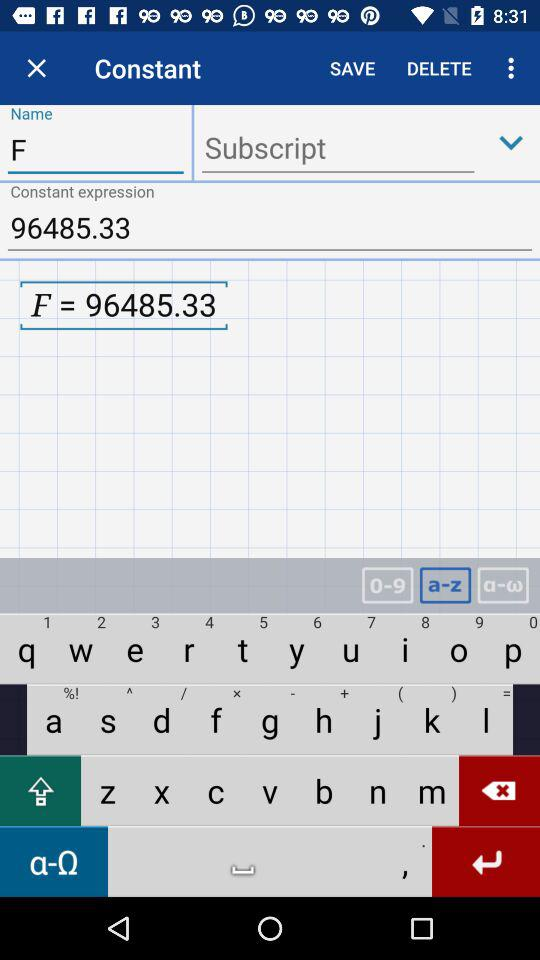What is the value of F? The value of F is 96485.33. 